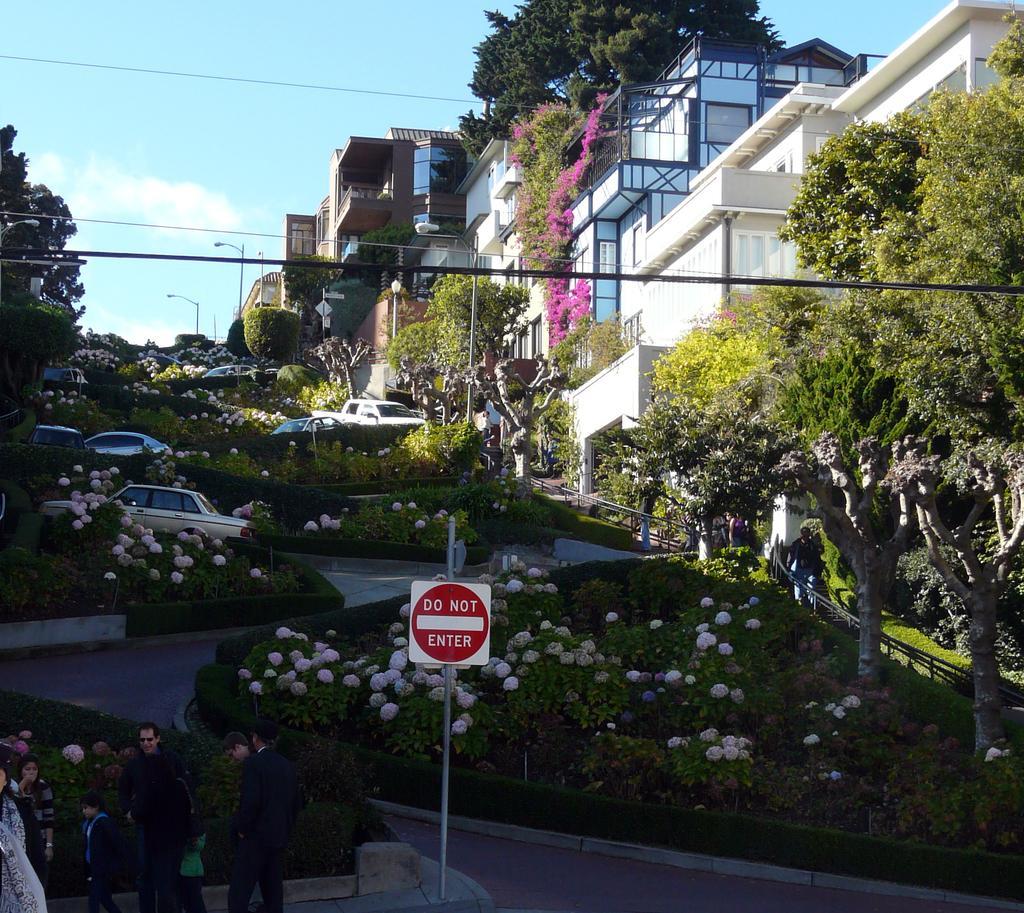Could you give a brief overview of what you see in this image? At the bottom of the image we can see a sign board. On the left there are people standing. In the background there are bushes, flowers, trees, buildings, poles and sky. 